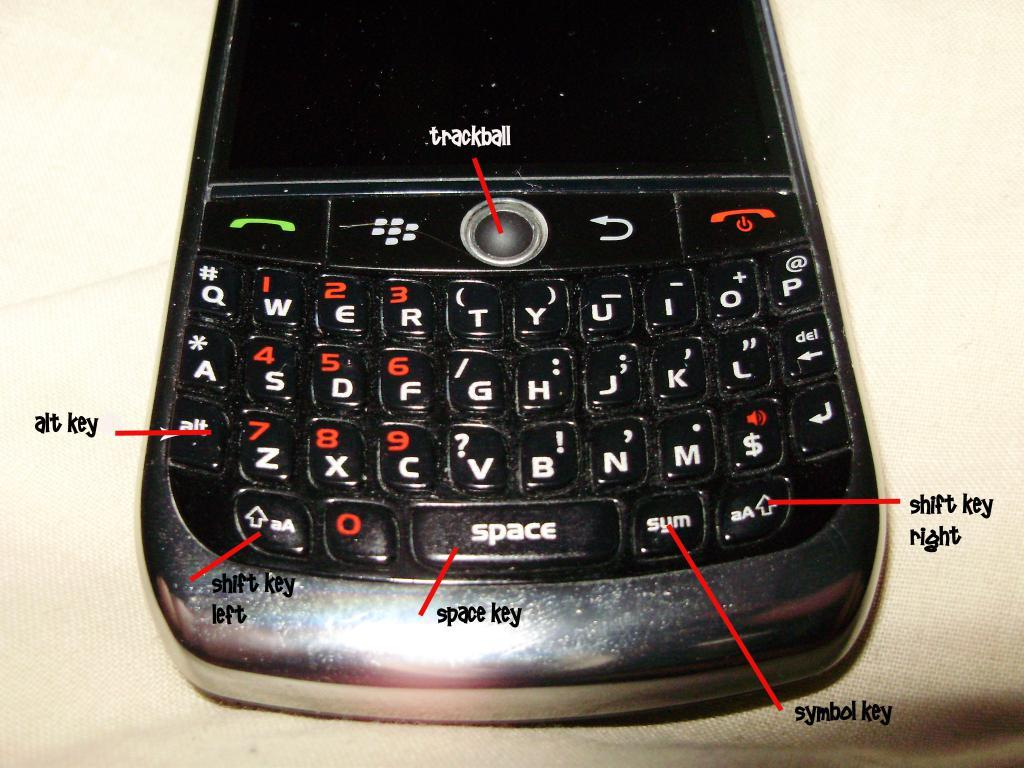<image>
Give a short and clear explanation of the subsequent image. A diagram shows buttons on a Blackberry phone including the trackball and the space key. 